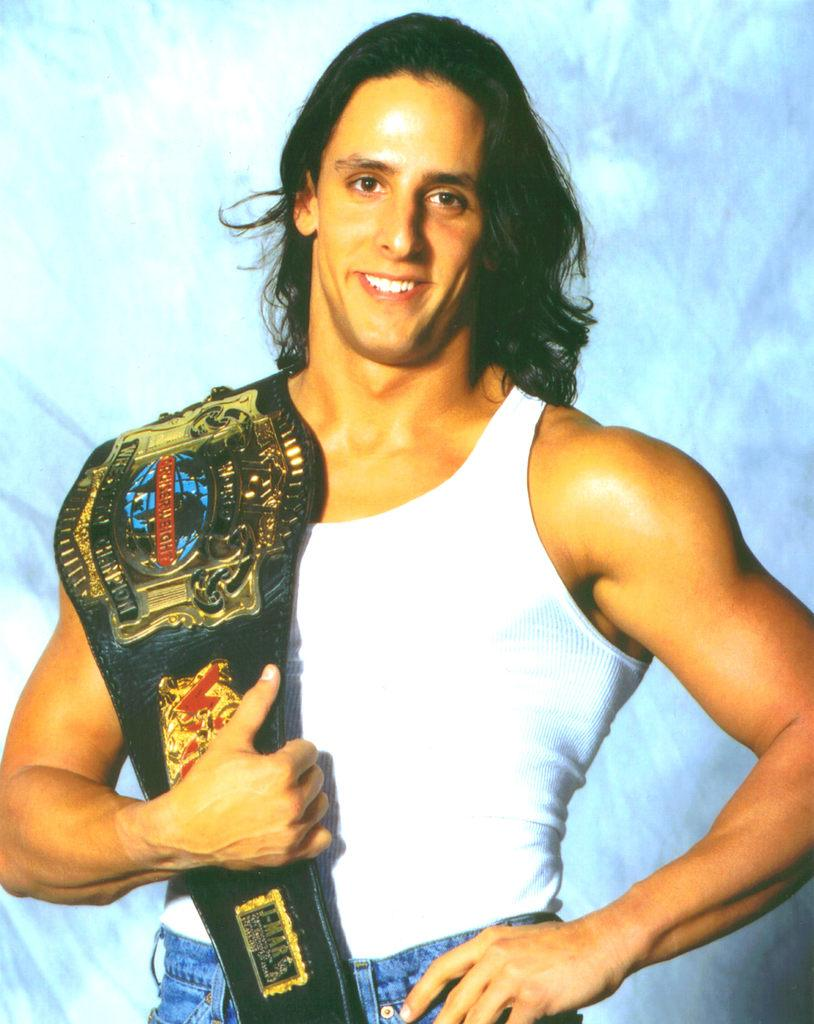Who is the main subject in the image? There is a person in the center of the image. What is the person holding in the image? The person is holding a wrestling belt. What is the facial expression of the person in the image? The person is smiling. What color is the background of the image? The background of the image is white. Can you hear the boy's voice in the image? There is no boy present in the image, and therefore no voice to hear. 